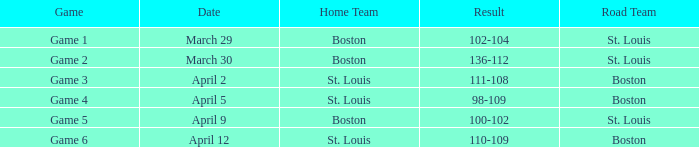What is the Game number on April 12 with St. Louis Home Team? Game 6. 